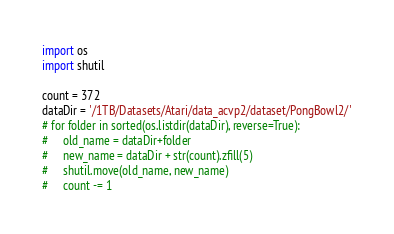Convert code to text. <code><loc_0><loc_0><loc_500><loc_500><_Python_>import os
import shutil

count = 372
dataDir = '/1TB/Datasets/Atari/data_acvp2/dataset/PongBowl2/'
# for folder in sorted(os.listdir(dataDir), reverse=True):
#     old_name = dataDir+folder
#     new_name = dataDir + str(count).zfill(5)
#     shutil.move(old_name, new_name)
#     count -= 1</code> 